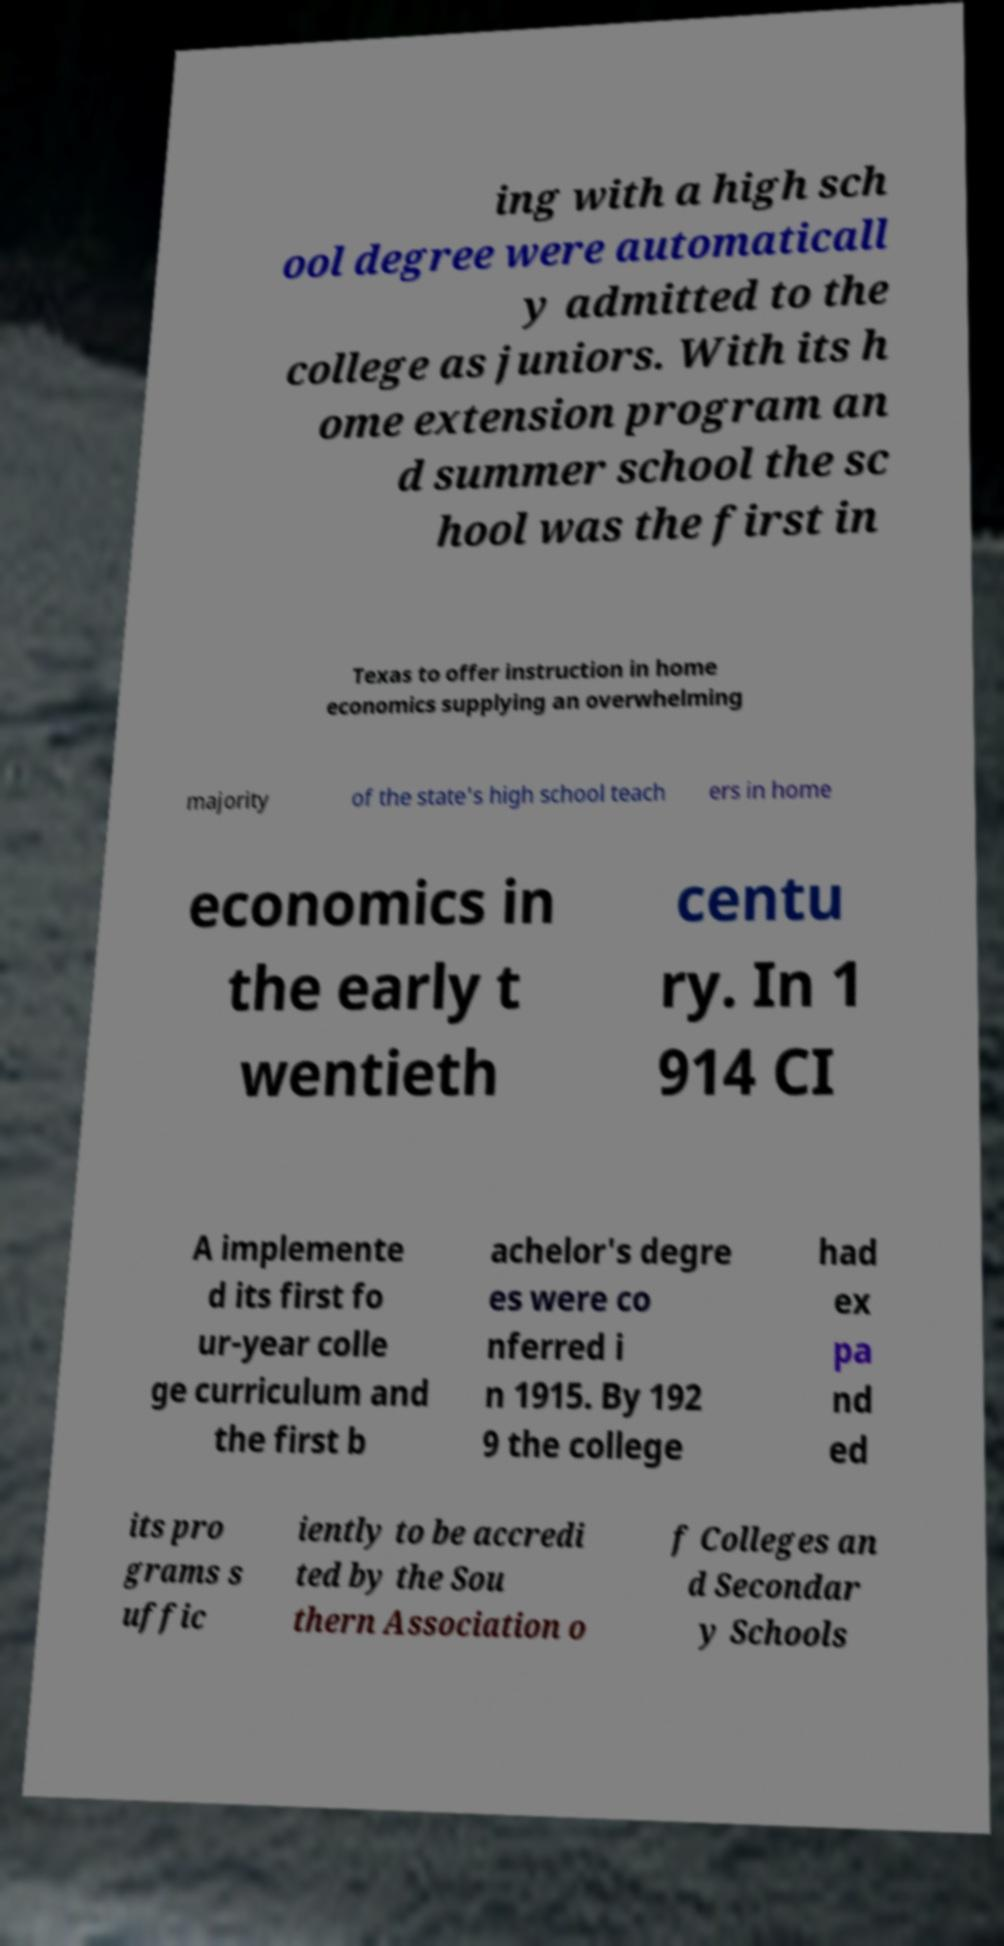For documentation purposes, I need the text within this image transcribed. Could you provide that? ing with a high sch ool degree were automaticall y admitted to the college as juniors. With its h ome extension program an d summer school the sc hool was the first in Texas to offer instruction in home economics supplying an overwhelming majority of the state's high school teach ers in home economics in the early t wentieth centu ry. In 1 914 CI A implemente d its first fo ur-year colle ge curriculum and the first b achelor's degre es were co nferred i n 1915. By 192 9 the college had ex pa nd ed its pro grams s uffic iently to be accredi ted by the Sou thern Association o f Colleges an d Secondar y Schools 